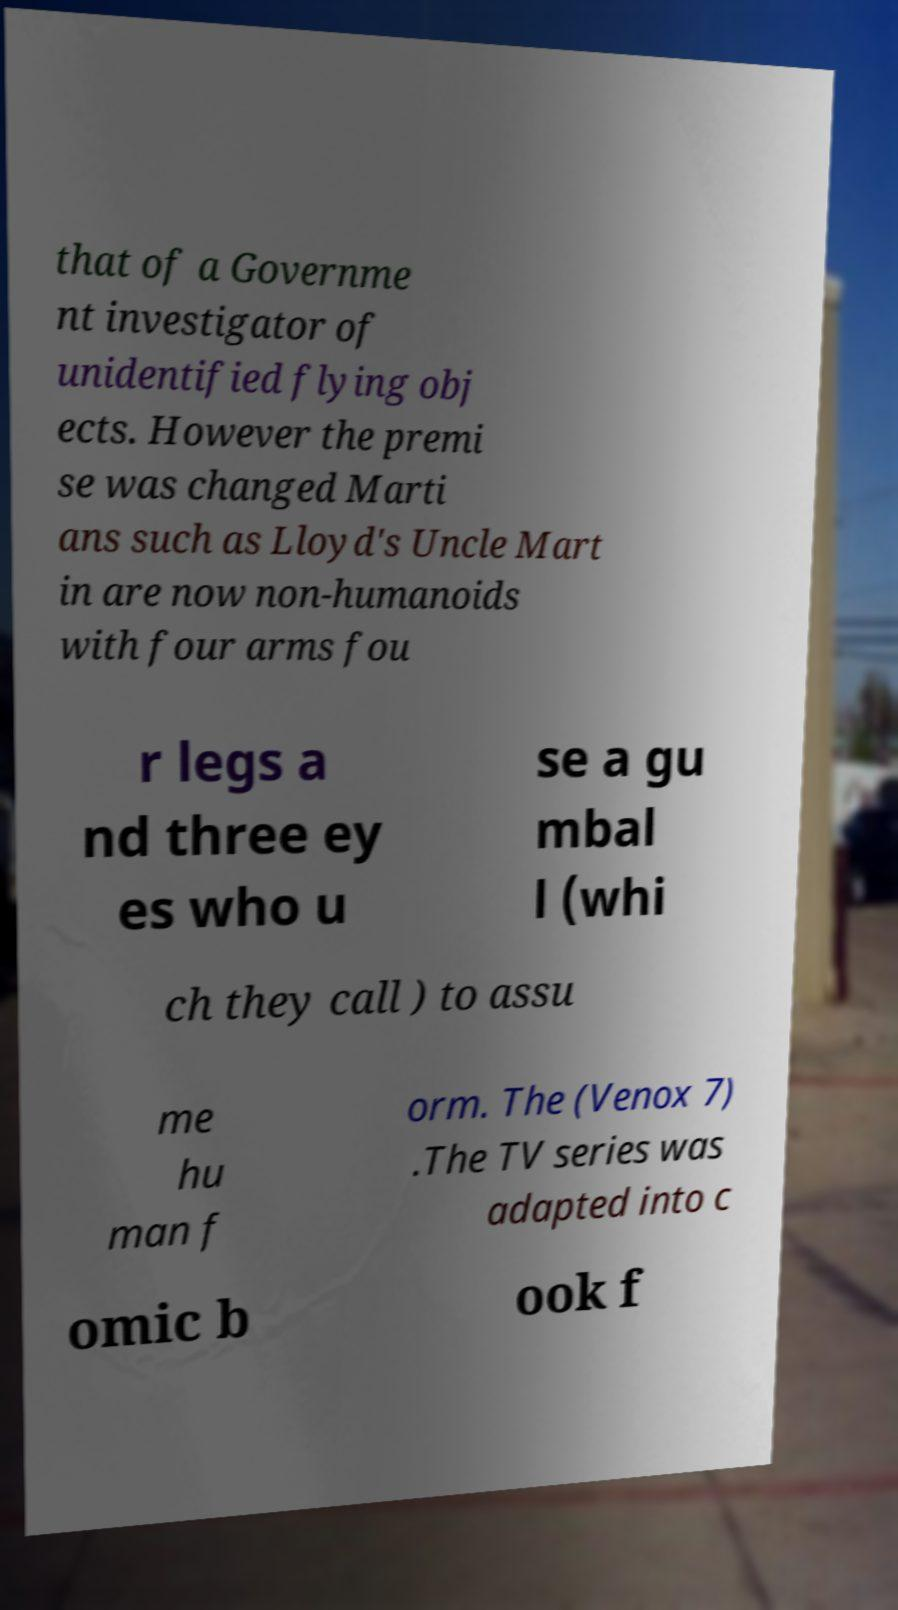Please read and relay the text visible in this image. What does it say? that of a Governme nt investigator of unidentified flying obj ects. However the premi se was changed Marti ans such as Lloyd's Uncle Mart in are now non-humanoids with four arms fou r legs a nd three ey es who u se a gu mbal l (whi ch they call ) to assu me hu man f orm. The (Venox 7) .The TV series was adapted into c omic b ook f 